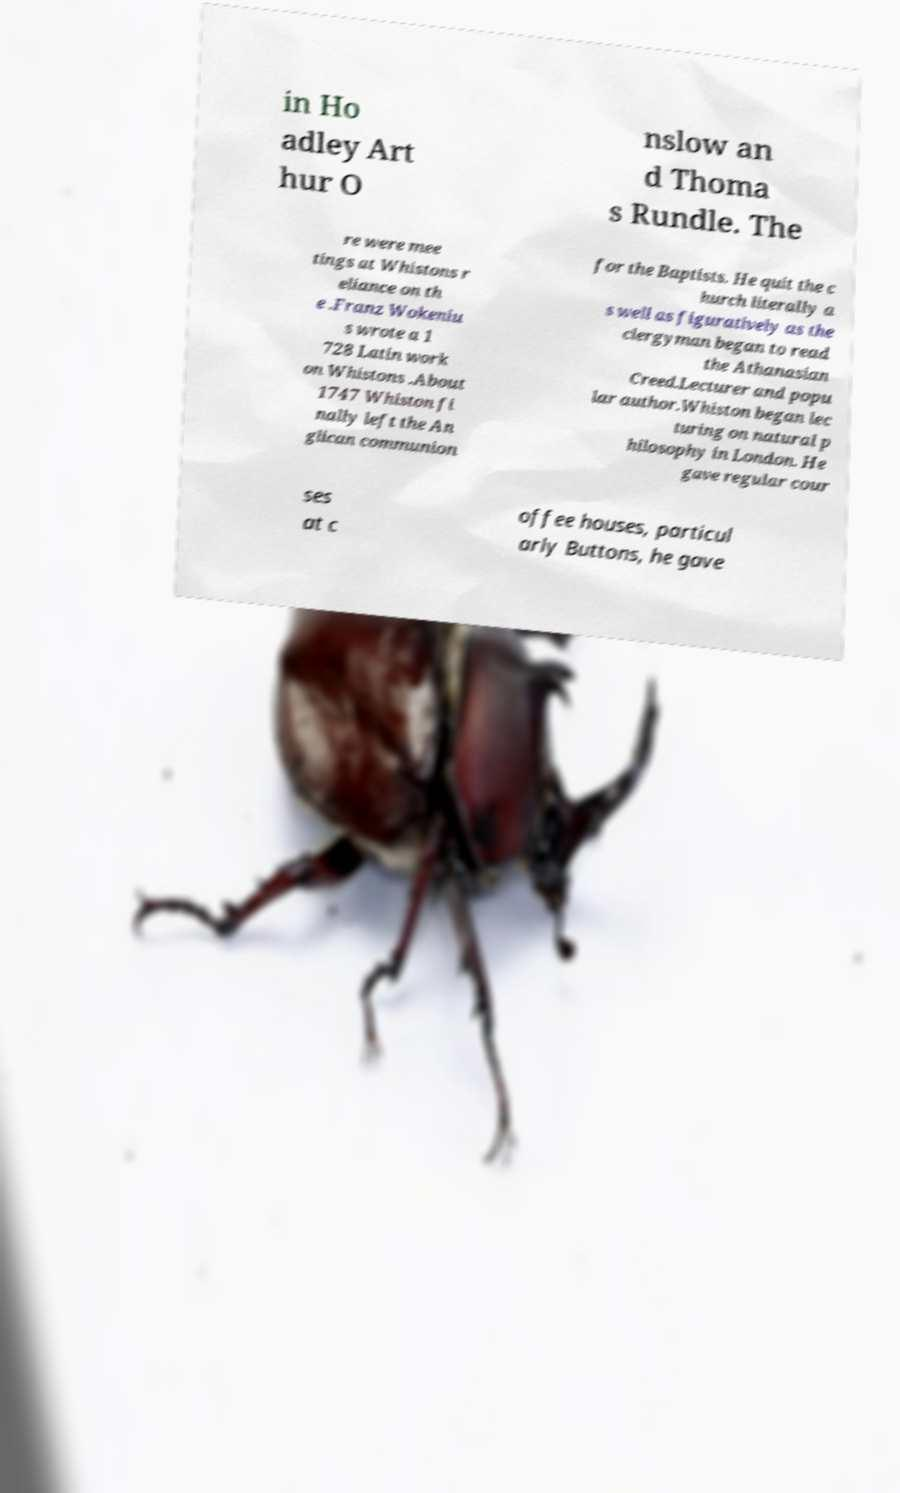For documentation purposes, I need the text within this image transcribed. Could you provide that? in Ho adley Art hur O nslow an d Thoma s Rundle. The re were mee tings at Whistons r eliance on th e .Franz Wokeniu s wrote a 1 728 Latin work on Whistons .About 1747 Whiston fi nally left the An glican communion for the Baptists. He quit the c hurch literally a s well as figuratively as the clergyman began to read the Athanasian Creed.Lecturer and popu lar author.Whiston began lec turing on natural p hilosophy in London. He gave regular cour ses at c offee houses, particul arly Buttons, he gave 